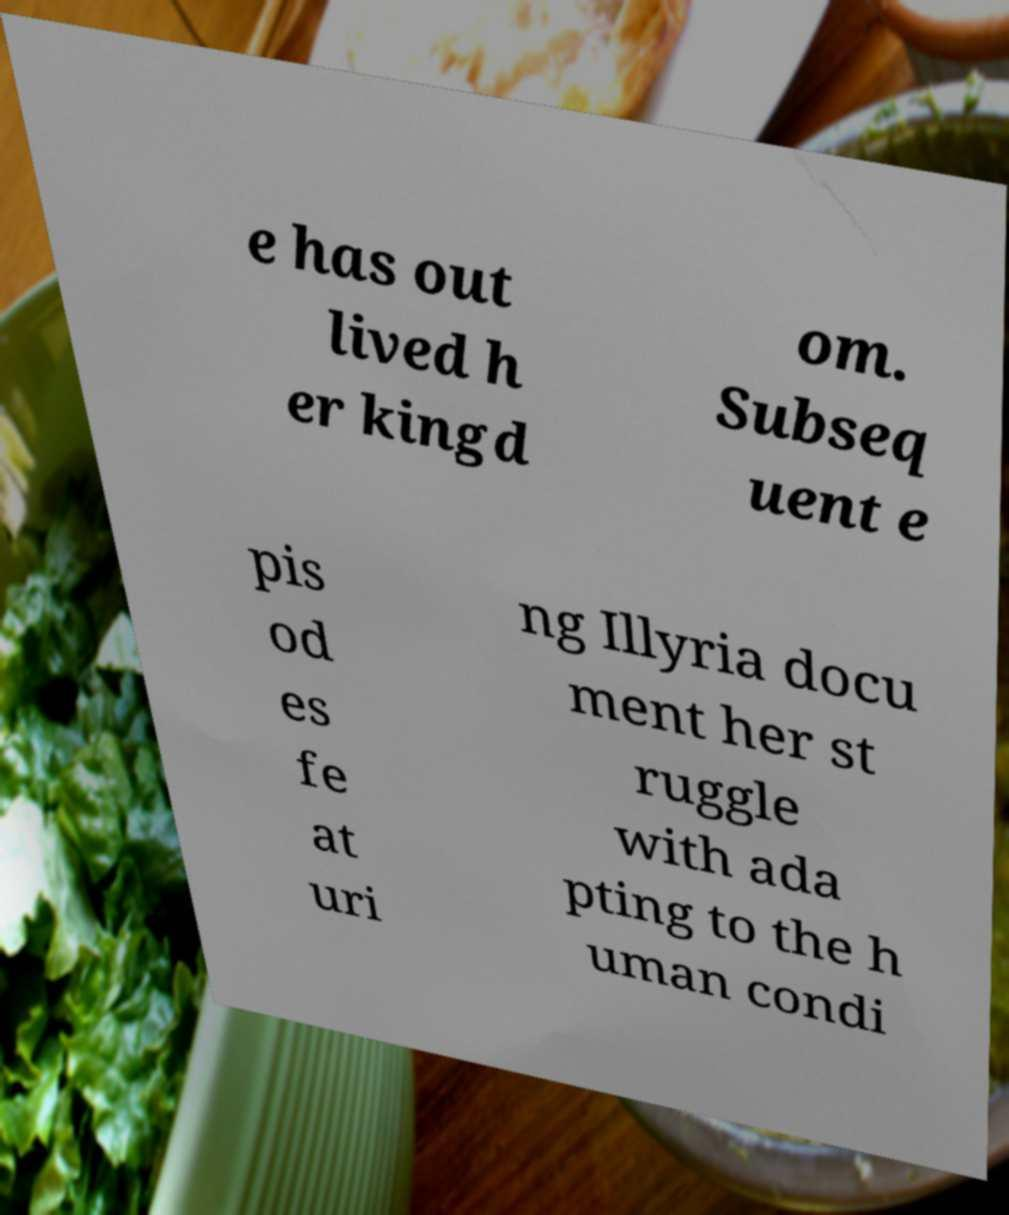Can you accurately transcribe the text from the provided image for me? e has out lived h er kingd om. Subseq uent e pis od es fe at uri ng Illyria docu ment her st ruggle with ada pting to the h uman condi 